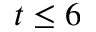<formula> <loc_0><loc_0><loc_500><loc_500>t \leq 6</formula> 